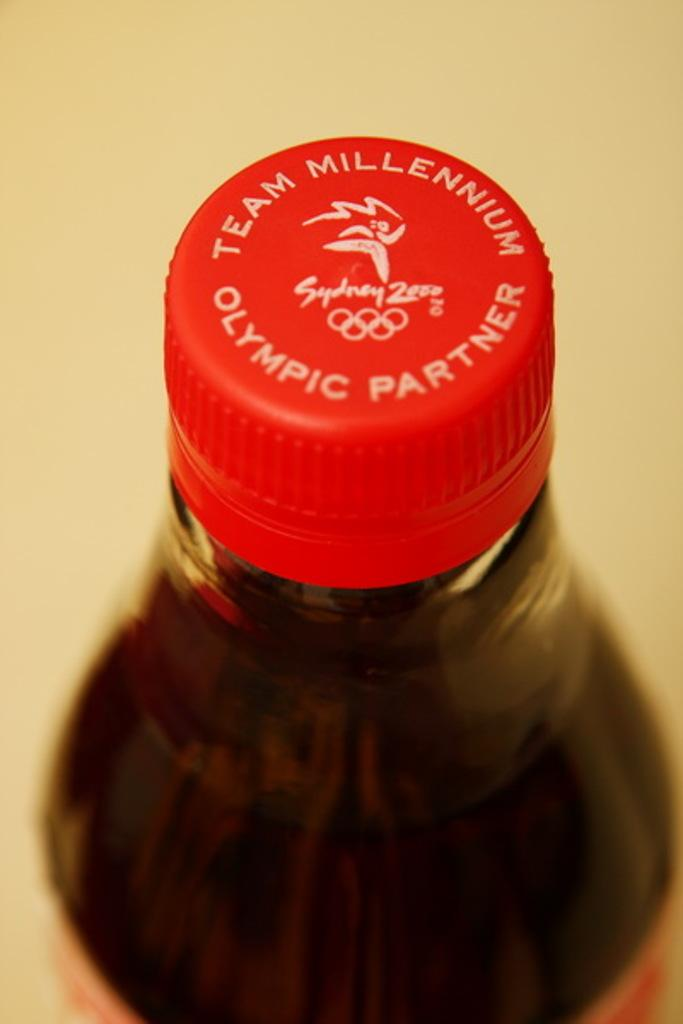<image>
Provide a brief description of the given image. the top of a bottle with the words 'olympic partner' on top of it. 